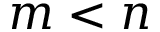<formula> <loc_0><loc_0><loc_500><loc_500>m < n</formula> 